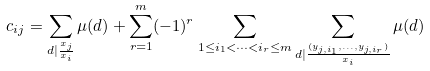<formula> <loc_0><loc_0><loc_500><loc_500>c _ { i j } = \sum _ { d | \frac { x _ { j } } { x _ { i } } } \mu ( d ) + \sum _ { r = 1 } ^ { m } ( - 1 ) ^ { r } \sum _ { 1 \leq i _ { 1 } < \dots < i _ { r } \leq m } \sum _ { d | \frac { ( y _ { j , i _ { 1 } } , \dots , y _ { j , i _ { r } } ) } { x _ { i } } } \mu ( d )</formula> 